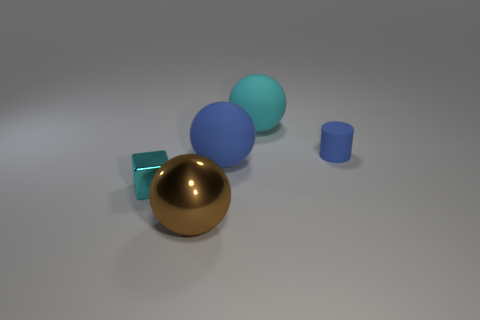Add 2 big blue rubber objects. How many objects exist? 7 Subtract all cylinders. How many objects are left? 4 Subtract all brown rubber cylinders. Subtract all matte balls. How many objects are left? 3 Add 3 small blue rubber cylinders. How many small blue rubber cylinders are left? 4 Add 4 large brown objects. How many large brown objects exist? 5 Subtract 0 yellow cylinders. How many objects are left? 5 